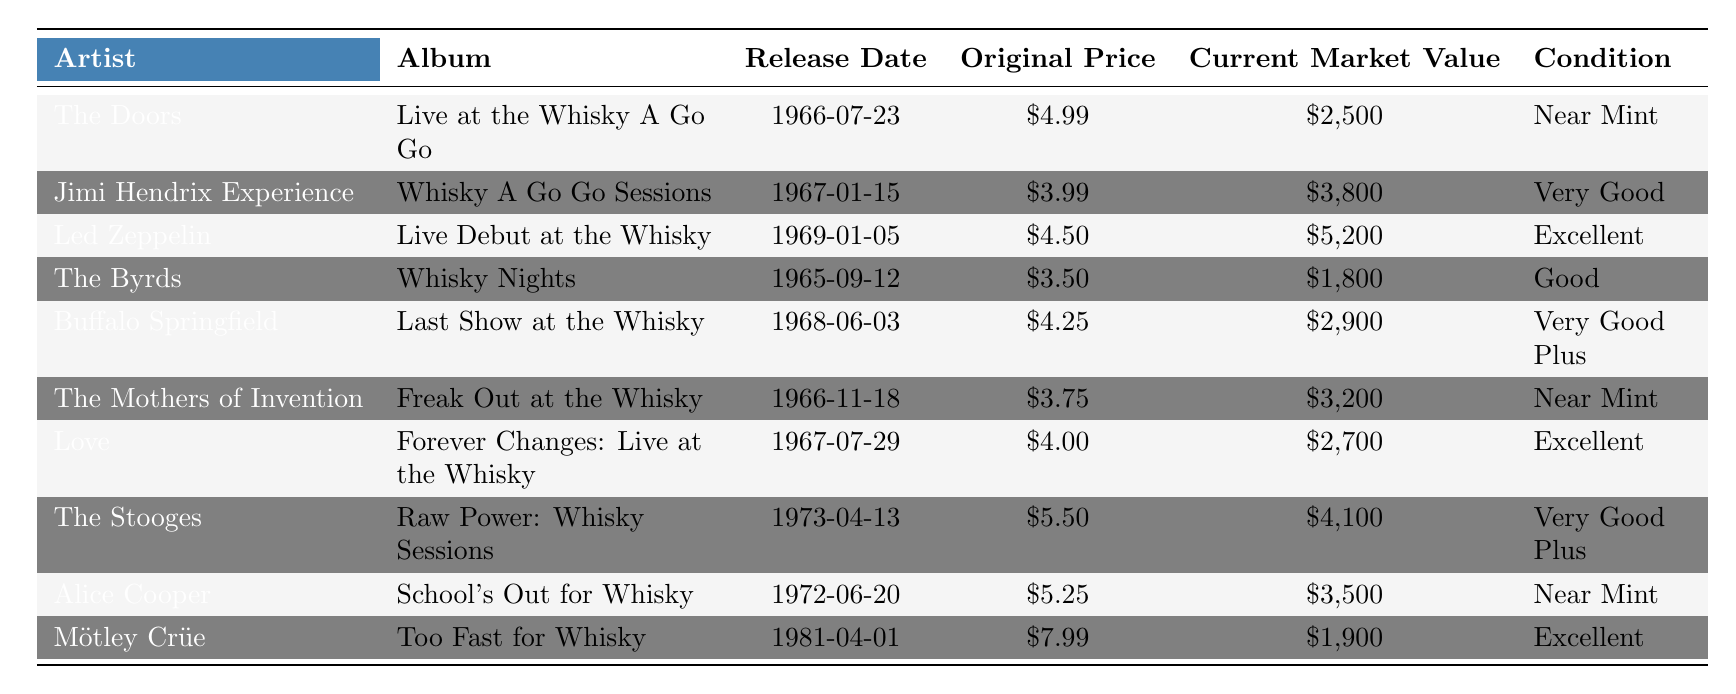What is the current market value of "Live at the Whisky A Go Go"? The current market value is directly stated in the table next to the album "Live at the Whisky A Go Go," which is listed as $2,500.
Answer: $2,500 Which artist has an album with the original price of $3.75? The table shows that the album "Freak Out at the Whisky" is listed under The Mothers of Invention with an original price of $3.75.
Answer: The Mothers of Invention What is the difference in current market value between "Whisky A Go Go Sessions" and "Whisky Nights"? The current market value of "Whisky A Go Go Sessions" is $3,800, and for "Whisky Nights," it is $1,800. The difference is $3,800 - $1,800 = $2,000.
Answer: $2,000 Which album has the highest current market value? To find the album with the highest current market value, we compare values in the "Current Market Value" column. "Live Debut at the Whisky" by Led Zeppelin has the highest value of $5,200.
Answer: Live Debut at the Whisky How many albums have a condition rated as "Excellent"? Looking at the Condition column, there are three albums that have an "Excellent" rating: "Live Debut at the Whisky," "Forever Changes: Live at the Whisky," and "Too Fast for Whisky." Therefore, the count is 3.
Answer: 3 Is the original price of "Too Fast for Whisky" higher than $5? The original price of "Too Fast for Whisky" is listed as $7.99, which is indeed higher than $5.
Answer: Yes What is the total original price of the albums listed? To find the total, sum up all original prices: $4.99 + $3.99 + $4.50 + $3.50 + $4.25 + $3.75 + $4.00 + $5.50 + $5.25 + $7.99 = $47.72.
Answer: $47.72 Which artist has an album released in 1965, and what is its current market value? The only artist with an album released in 1965 is The Byrds with "Whisky Nights," and its current market value is $1,800.
Answer: $1,800 If I bought "Last Show at the Whisky" for its original price, how much profit would I make if I sold it at current market value? The original price of "Last Show at the Whisky" is $4.25, and its current market value is $2,900. To find the profit, calculate $2,900 - $4.25 = $2,895.75.
Answer: $2,895.75 What percentage of the albums in the table are rated as "Near Mint"? There are two albums rated "Near Mint": "Live at the Whisky A Go Go" and "Freak Out at the Whisky," while there are 10 albums total. The percentage is (2/10) * 100 = 20%.
Answer: 20% 